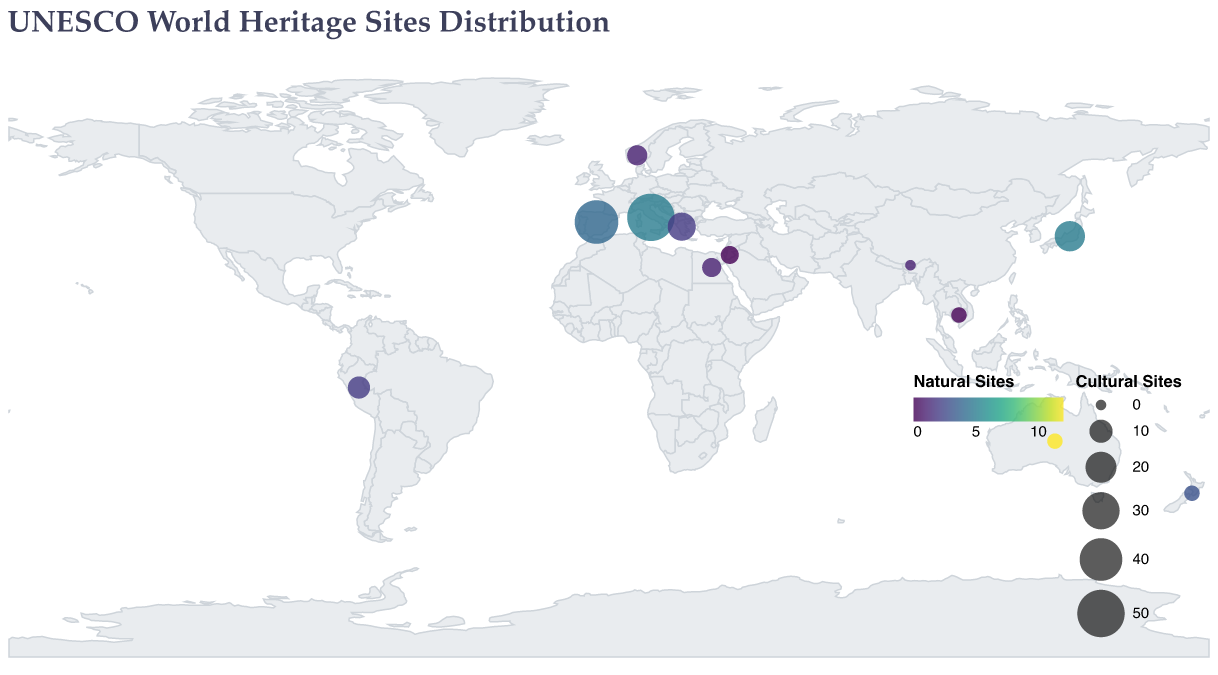Which country has the highest number of cultural sites? By looking at the sizes of the circles representing cultural sites, the largest circle indicates the country with the most cultural sites. Italy has the largest circle.
Answer: Italy How many natural sites does Australia have? By examining the color intensity of the circle representing Australia, which is on the right color scale legend indicating natural sites, we see a higher count.
Answer: 12 Which countries have exactly 3 cultural sites? By checking the legend-determined smaller circles and hovering over the tooltips, we find that Cambodia, Australia, and New Zealand have 3 cultural sites.
Answer: Cambodia, Australia, New Zealand Which country has more natural sites: Japan or Greece? By comparing the color intensity of the circles for Japan and Greece, Japan has a darker color indicating more natural sites.
Answer: Japan Between Spain and Egypt, which country has more cultural sites? By comparing the sizes of the circles for Spain and Egypt, Spain has a larger circle indicating more cultural sites.
Answer: Spain What is the total number of cultural sites in Italy and Greece combined? Italy has 50 cultural sites and Greece has 16, so combined total is 50 + 16.
Answer: 66 How many countries have more natural sites than cultural sites? By examining the tooltip data for each circle, Australia is the only country with more natural sites (12) than cultural sites (3).
Answer: 1 Which country with both cultural and natural sites has the smallest total count of sites? By summing the values of cultural and natural sites for each country and comparing, Cambodia has a total of 3 cultural sites and 0 natural sites making a total of 3.
Answer: Cambodia Which country in the Southern Hemisphere has more heritage sites: Peru or New Zealand? By comparing the sizes of the circles and tooltip data for Peru and New Zealand, Peru has 11 sites (9 cultural + 2 natural) and New Zealand has 6 sites (3 cultural + 3 natural).
Answer: Peru 